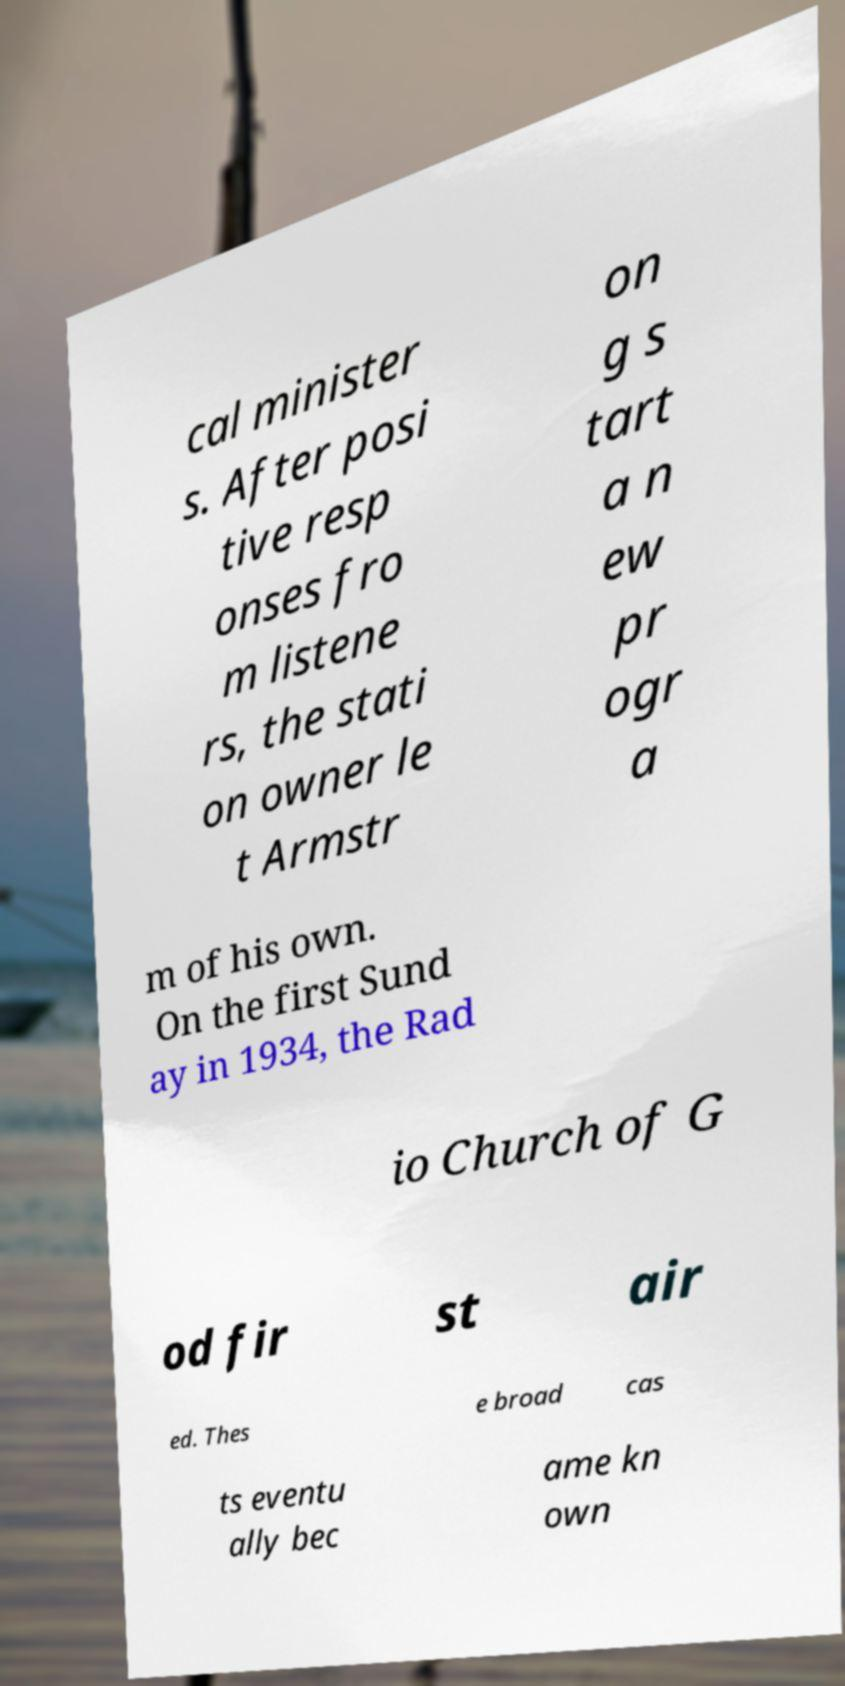Could you assist in decoding the text presented in this image and type it out clearly? cal minister s. After posi tive resp onses fro m listene rs, the stati on owner le t Armstr on g s tart a n ew pr ogr a m of his own. On the first Sund ay in 1934, the Rad io Church of G od fir st air ed. Thes e broad cas ts eventu ally bec ame kn own 